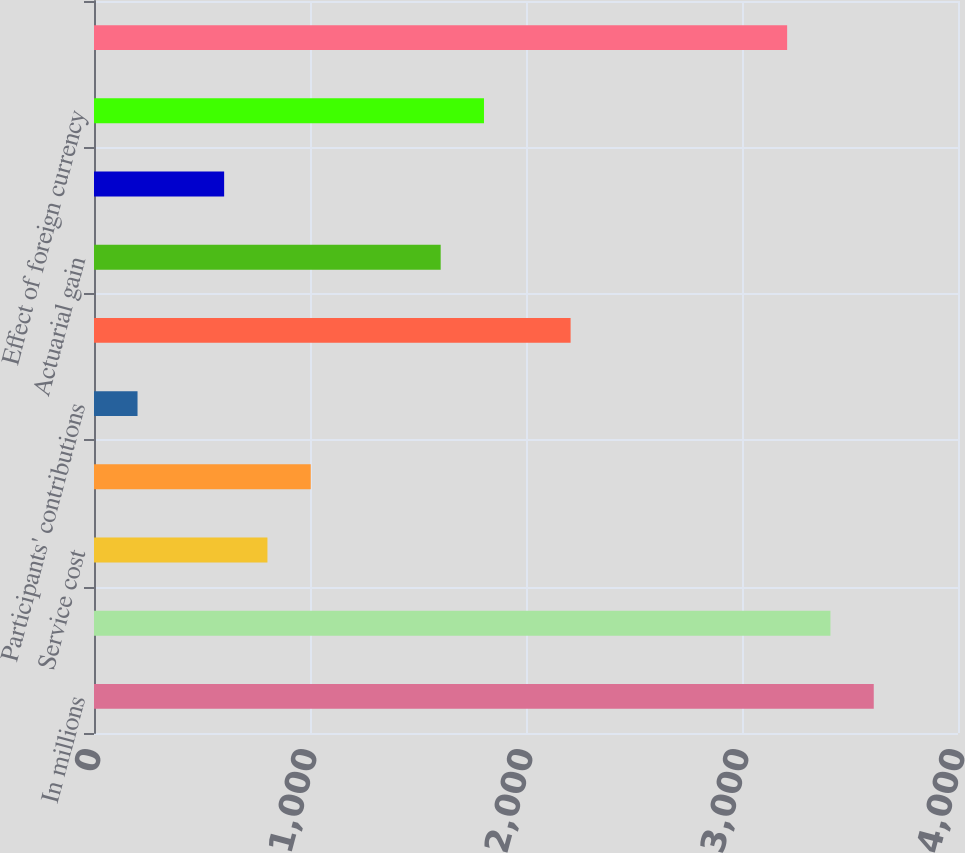Convert chart to OTSL. <chart><loc_0><loc_0><loc_500><loc_500><bar_chart><fcel>In millions<fcel>Benefit obligation January 1<fcel>Service cost<fcel>Interest cost<fcel>Participants' contributions<fcel>Divestitures<fcel>Actuarial gain<fcel>Benefits paid<fcel>Effect of foreign currency<fcel>Benefit obligation December 31<nl><fcel>3610<fcel>3409.5<fcel>803<fcel>1003.5<fcel>201.5<fcel>2206.5<fcel>1605<fcel>602.5<fcel>1805.5<fcel>3209<nl></chart> 